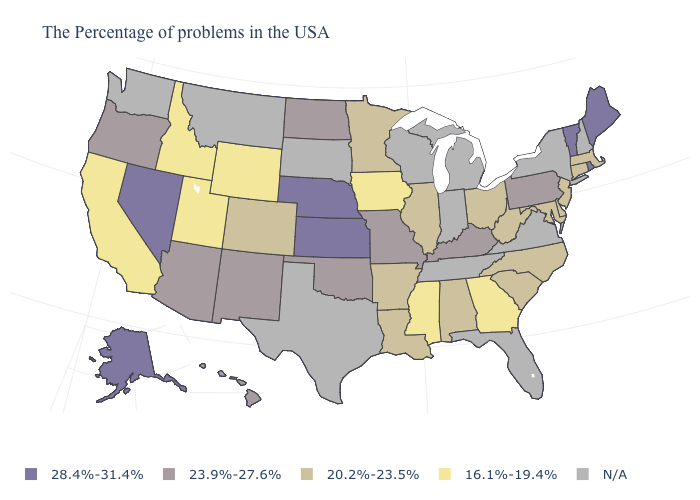Does the first symbol in the legend represent the smallest category?
Short answer required. No. What is the value of Utah?
Write a very short answer. 16.1%-19.4%. Is the legend a continuous bar?
Short answer required. No. Does Kansas have the highest value in the MidWest?
Concise answer only. Yes. Which states have the lowest value in the USA?
Write a very short answer. Georgia, Mississippi, Iowa, Wyoming, Utah, Idaho, California. Name the states that have a value in the range 23.9%-27.6%?
Write a very short answer. Pennsylvania, Kentucky, Missouri, Oklahoma, North Dakota, New Mexico, Arizona, Oregon, Hawaii. What is the value of Oklahoma?
Answer briefly. 23.9%-27.6%. What is the value of Maine?
Answer briefly. 28.4%-31.4%. What is the highest value in the South ?
Concise answer only. 23.9%-27.6%. What is the highest value in states that border Louisiana?
Write a very short answer. 20.2%-23.5%. Does Nebraska have the highest value in the MidWest?
Concise answer only. Yes. What is the value of New Hampshire?
Short answer required. N/A. Name the states that have a value in the range 16.1%-19.4%?
Give a very brief answer. Georgia, Mississippi, Iowa, Wyoming, Utah, Idaho, California. Does Colorado have the lowest value in the West?
Concise answer only. No. 